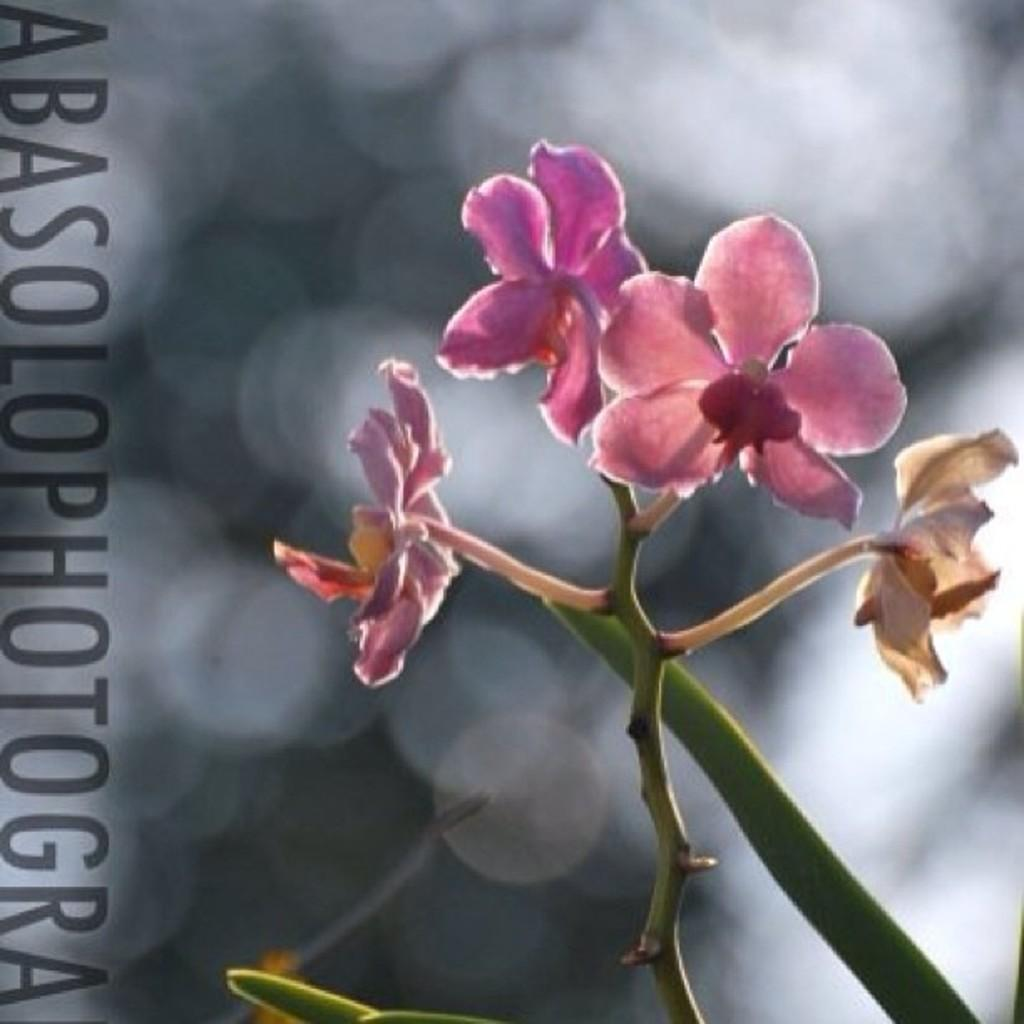What type of flora is present in the image? There are flowers in the image. What color are the flowers? The flowers are pink in color. What else can be seen at the bottom of the image? There is a plant at the bottom of the image. How would you describe the background of the image? The background of the image is blurred. What is located to the left of the image? There is text to the left of the image. How many straws are placed in the cart next to the books in the image? There are no straws, cart, or books present in the image. 